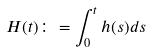Convert formula to latex. <formula><loc_0><loc_0><loc_500><loc_500>H ( t ) \colon = \int _ { 0 } ^ { t } h ( s ) d s</formula> 